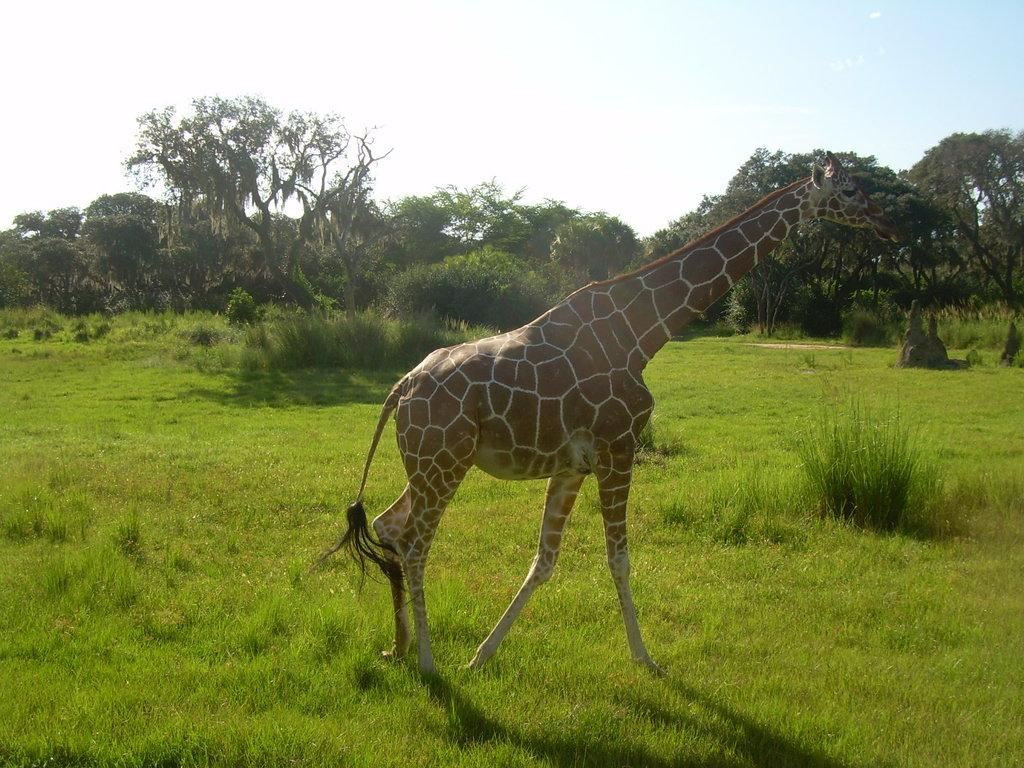What type of vegetation covers the land in the image? The land in the image is covered with grass. What animal can be seen in the image? A giraffe is present in the image. In which direction is the giraffe facing? The giraffe is facing towards the right side of the image. What can be seen in the background of the image? There are trees and plants in the background of the image. What type of support can be seen holding up the straw in the image? There is no straw present in the image, so there is no support for it. 